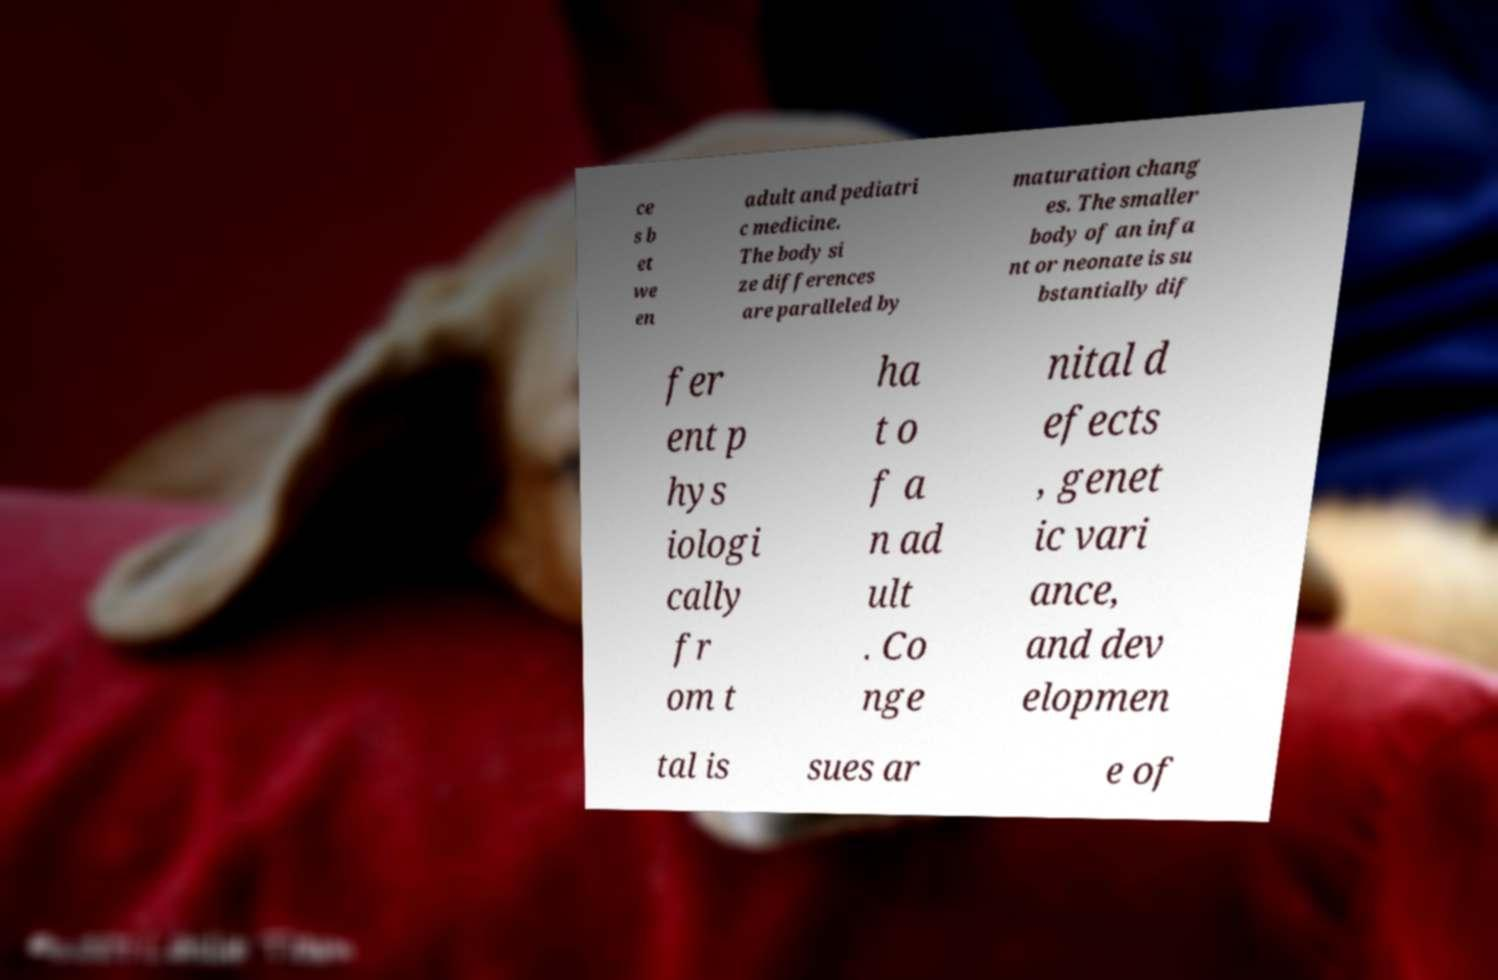For documentation purposes, I need the text within this image transcribed. Could you provide that? ce s b et we en adult and pediatri c medicine. The body si ze differences are paralleled by maturation chang es. The smaller body of an infa nt or neonate is su bstantially dif fer ent p hys iologi cally fr om t ha t o f a n ad ult . Co nge nital d efects , genet ic vari ance, and dev elopmen tal is sues ar e of 